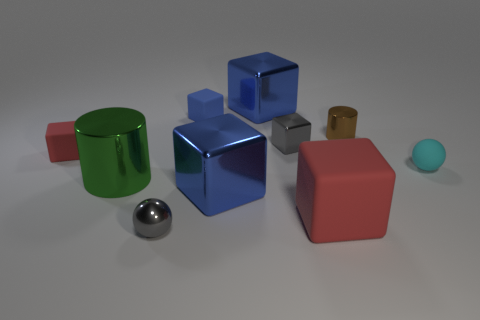There is a small matte thing that is both in front of the tiny blue object and on the left side of the small brown object; what shape is it?
Your response must be concise. Cube. Do the brown cylinder and the cyan matte thing have the same size?
Provide a short and direct response. Yes. Are there any other things that have the same material as the tiny cyan thing?
Provide a succinct answer. Yes. There is another rubber cube that is the same color as the large rubber cube; what size is it?
Make the answer very short. Small. What number of objects are to the left of the metallic sphere and behind the tiny red matte cube?
Give a very brief answer. 0. There is a tiny object that is on the right side of the brown cylinder; what material is it?
Ensure brevity in your answer.  Rubber. What number of tiny blocks have the same color as the big matte block?
Offer a terse response. 1. What size is the other red object that is the same material as the tiny red object?
Your answer should be compact. Large. What number of things are large green metal objects or red blocks?
Offer a terse response. 3. There is a tiny metallic object that is in front of the tiny red thing; what is its color?
Offer a very short reply. Gray. 